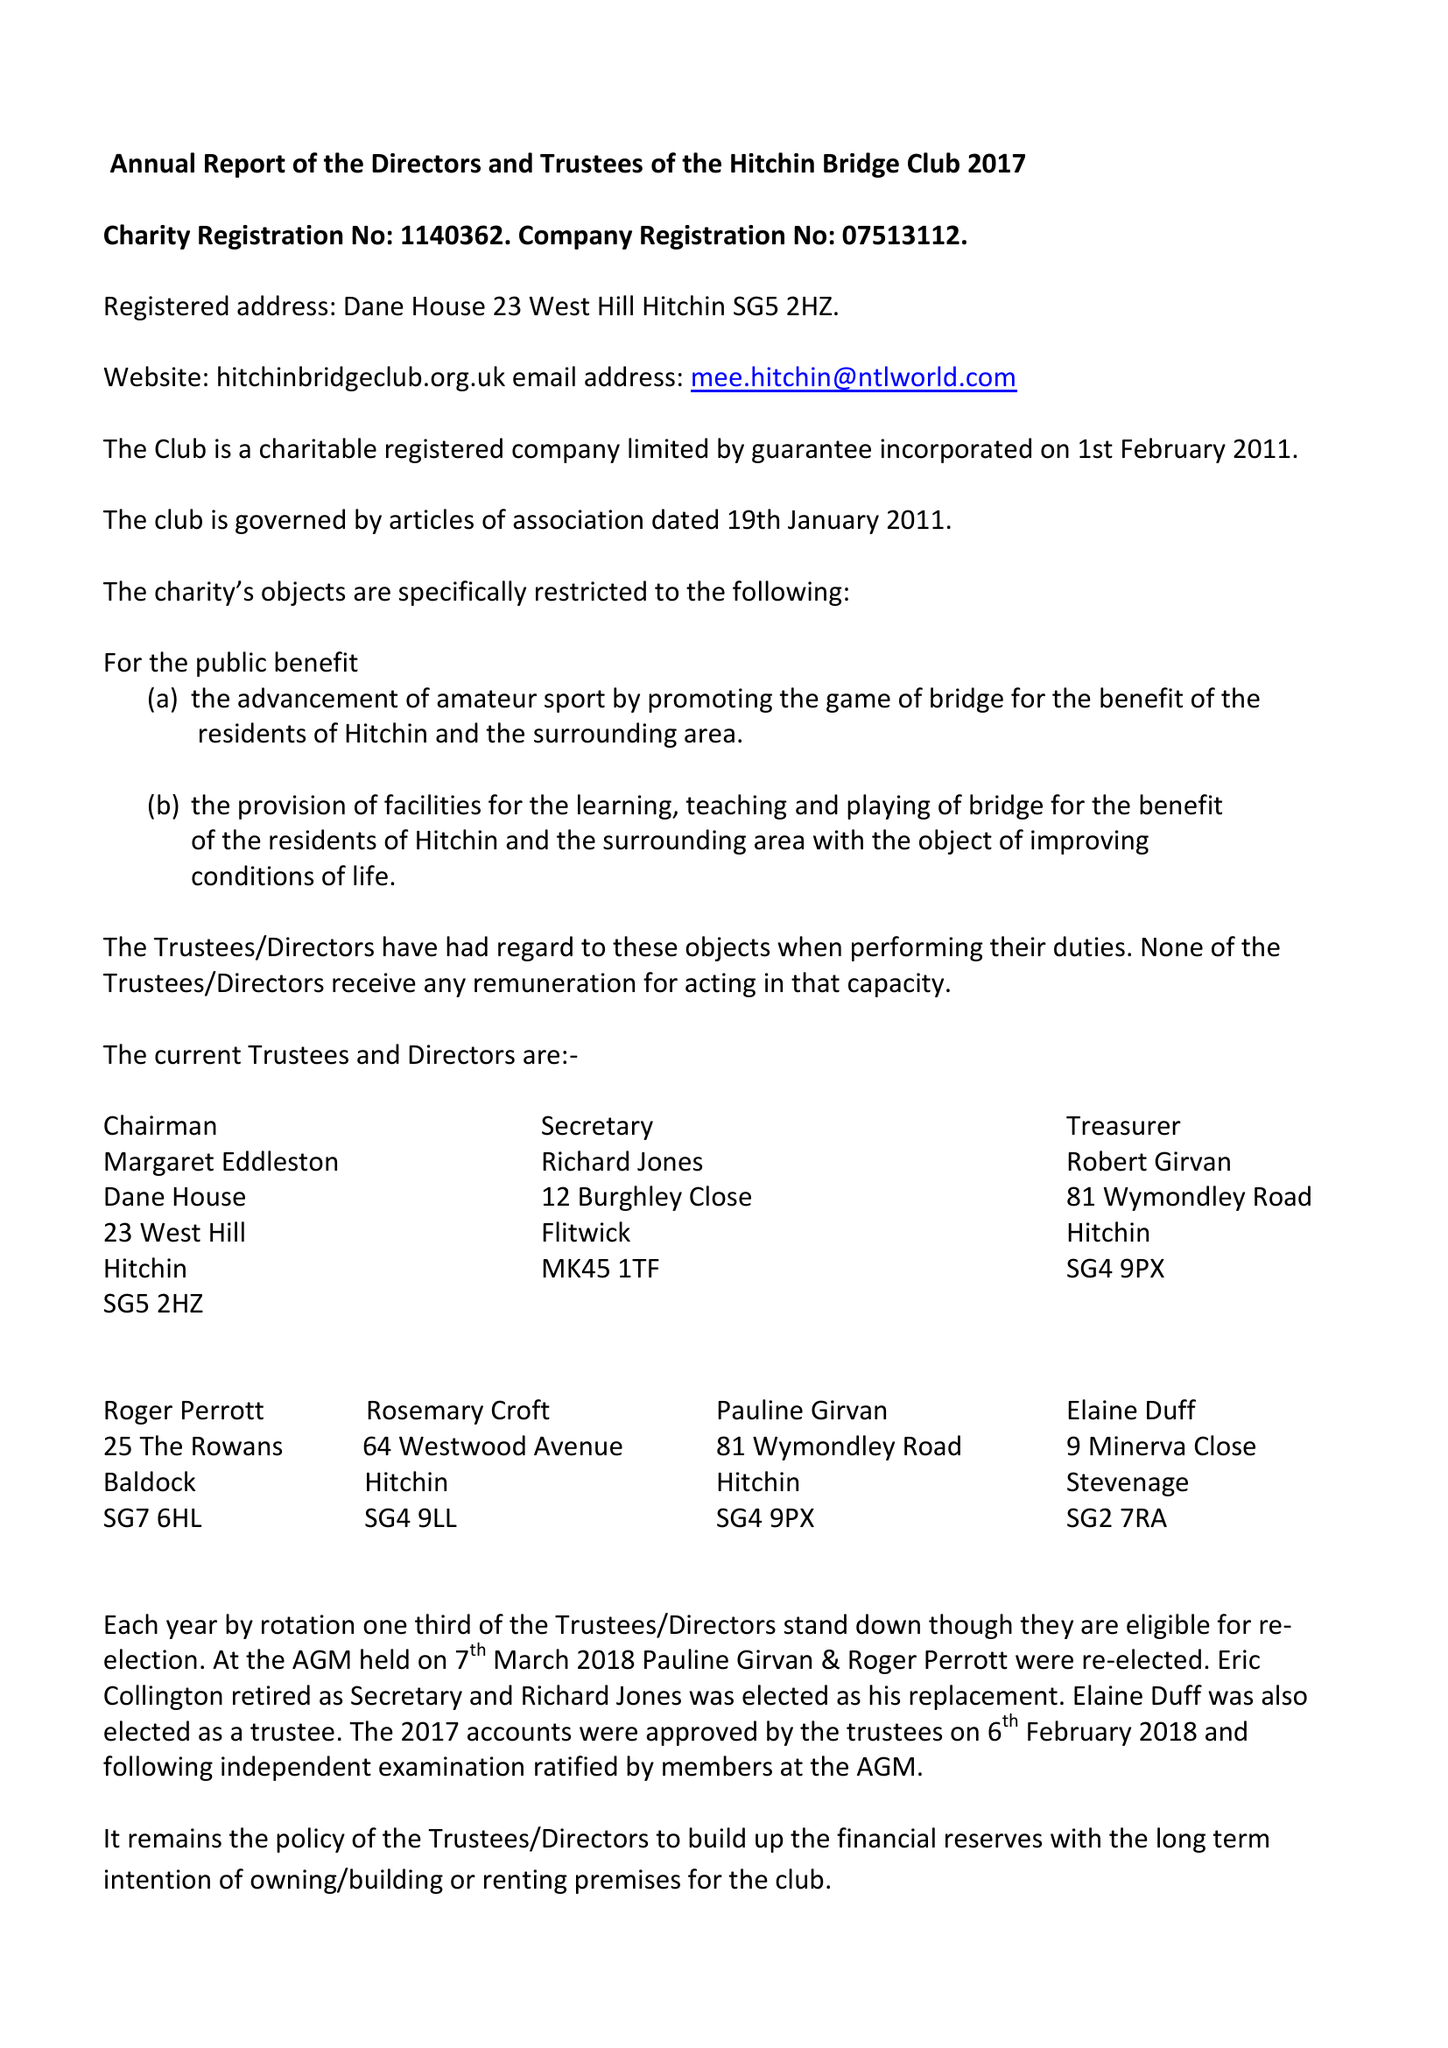What is the value for the charity_name?
Answer the question using a single word or phrase. Hitchin Bridge Club 